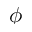Convert formula to latex. <formula><loc_0><loc_0><loc_500><loc_500>\phi</formula> 